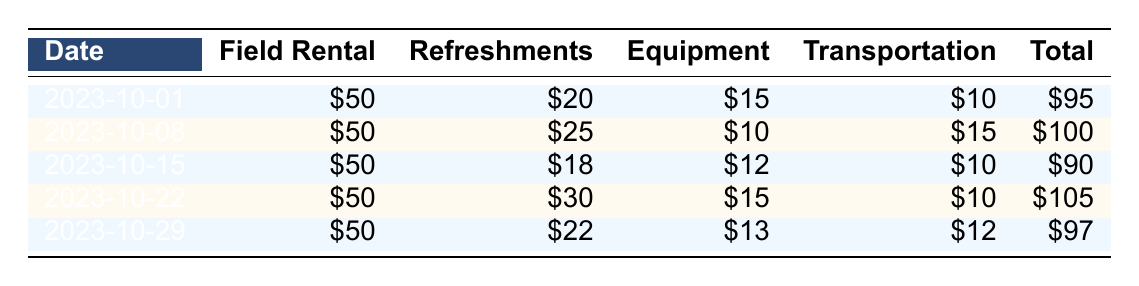What was the total expense for the week of October 15, 2023? The table shows that the total expense for the week of October 15, 2023, is directly listed in the "Total" column for that date. Referring to the row for October 15, the total expense is \(90\).
Answer: 90 How much was spent on refreshments in total over the five weeks? To find the total spent on refreshments, we need to sum the values in the "Refreshments" column for each week: \(20 + 25 + 18 + 30 + 22 = 115\). Thus, the total for refreshments is \(115\).
Answer: 115 Was there ever an expense over $100 throughout the five weeks? Looking through the "Total" column in the table, we see two expenses listed: \(100\) on October 8 and \(105\) on October 22. Both exceed \(100\), thus the answer is yes.
Answer: Yes What was the average total expense across all weeks? To calculate the average total expense, we first sum all the expenses: \(95 + 100 + 90 + 105 + 97 = 487\). Then, we divide the total by the number of weeks: \(487 / 5 = 97.4\). So, the average total expense is \(97.4\).
Answer: 97.4 Which week had the highest cost for transportation? We examine the "Transportation" column for each week: \(10\), \(15\), \(10\), \(10\), and \(12\). The highest value is \(15\), which occurred on October 8, 2023.
Answer: October 8 What was the change in total expenses from October 1 to October 29? The total expense on October 1 was \(95\), and on October 29 it was \(97\). To find the change, we calculate \(97 - 95 = 2\). Thus, the change is an increase of \(2\).
Answer: 2 Did the equipment expenses ever go below $10? Checking the "Equipment" column, the values are \(15\), \(10\), \(12\), \(15\), and \(13\). Since all values are above \(10\), the answer is no.
Answer: No What is the total amount spent on field rentals over the five weeks? Since the field rental cost is constant at \(50\) for each week, we multiply \(50\) by \(5\) weeks, giving us \(250\) as the total amount spent on field rentals.
Answer: 250 